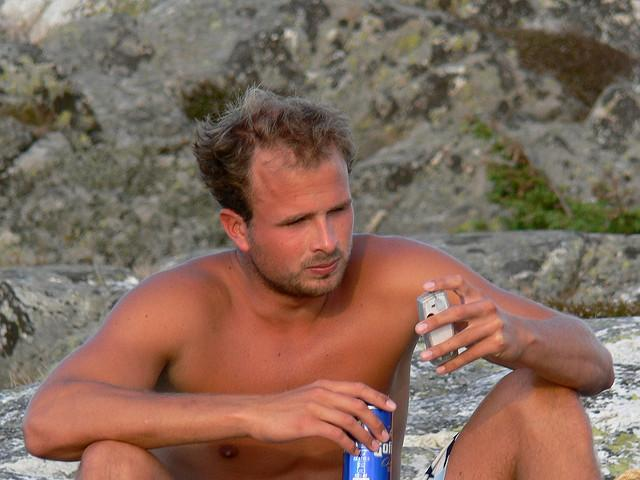What is the man holding? Please explain your reasoning. can. The man has a beer can. 